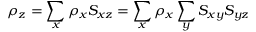<formula> <loc_0><loc_0><loc_500><loc_500>\rho _ { z } = \sum _ { x } \rho _ { x } S _ { x z } = \sum _ { x } \rho _ { x } \sum _ { y } S _ { x y } S _ { y z }</formula> 